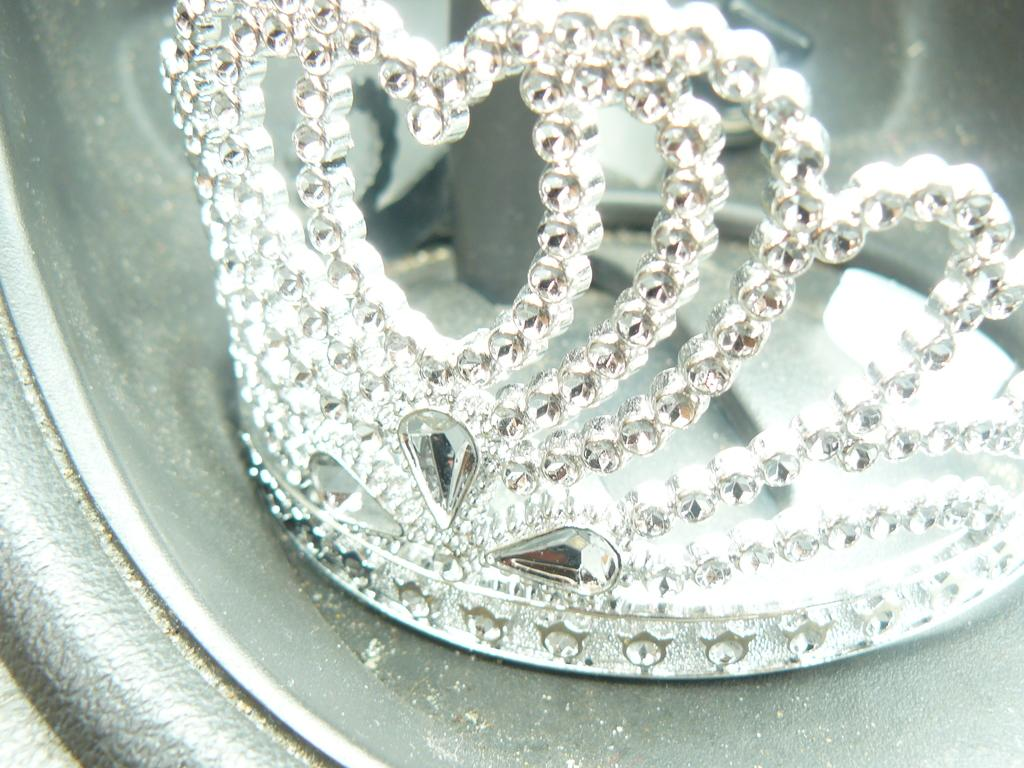What object is the main focus of the image? There is a crown in the image. Where is the crown located? The crown is placed in a container. What type of coal is used to smash the needle in the image? There is no coal, smashing, or needle present in the image; it only features a crown in a container. 